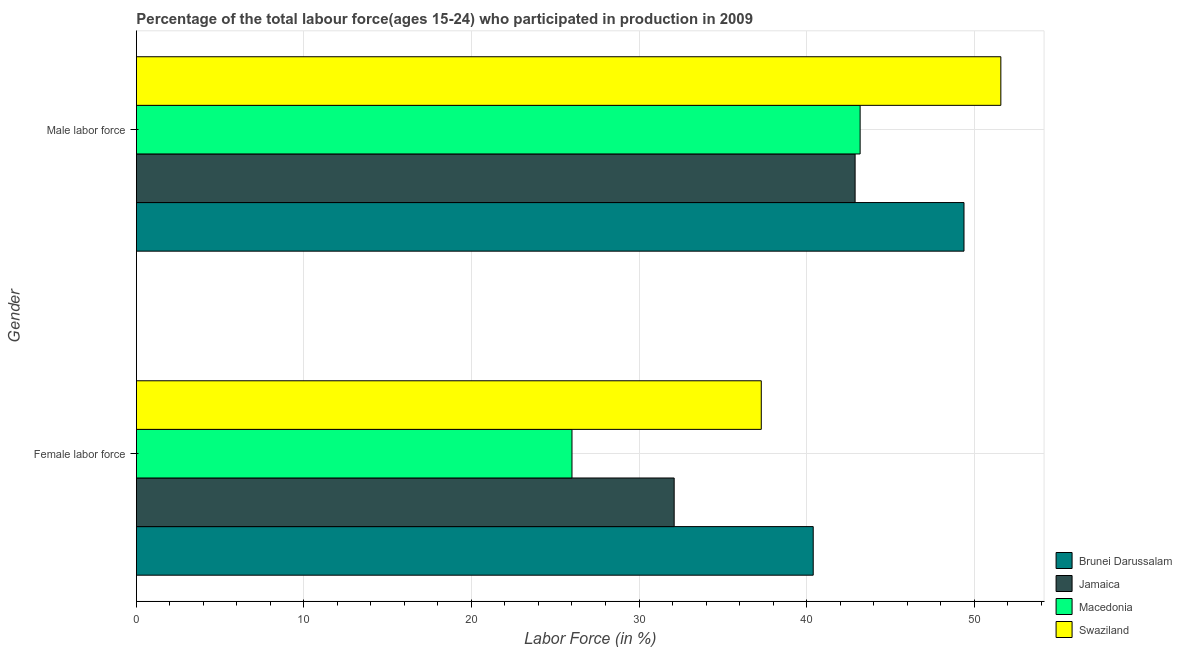How many groups of bars are there?
Give a very brief answer. 2. Are the number of bars per tick equal to the number of legend labels?
Your response must be concise. Yes. What is the label of the 1st group of bars from the top?
Your answer should be very brief. Male labor force. What is the percentage of male labour force in Brunei Darussalam?
Make the answer very short. 49.4. Across all countries, what is the maximum percentage of male labour force?
Your answer should be compact. 51.6. Across all countries, what is the minimum percentage of male labour force?
Offer a very short reply. 42.9. In which country was the percentage of female labor force maximum?
Provide a succinct answer. Brunei Darussalam. In which country was the percentage of male labour force minimum?
Offer a terse response. Jamaica. What is the total percentage of female labor force in the graph?
Your response must be concise. 135.8. What is the difference between the percentage of female labor force in Macedonia and that in Jamaica?
Keep it short and to the point. -6.1. What is the difference between the percentage of male labour force in Brunei Darussalam and the percentage of female labor force in Jamaica?
Ensure brevity in your answer.  17.3. What is the average percentage of male labour force per country?
Make the answer very short. 46.78. What is the difference between the percentage of female labor force and percentage of male labour force in Brunei Darussalam?
Your answer should be very brief. -9. What is the ratio of the percentage of male labour force in Swaziland to that in Macedonia?
Ensure brevity in your answer.  1.19. In how many countries, is the percentage of female labor force greater than the average percentage of female labor force taken over all countries?
Your answer should be very brief. 2. What does the 2nd bar from the top in Male labor force represents?
Your response must be concise. Macedonia. What does the 4th bar from the bottom in Female labor force represents?
Provide a short and direct response. Swaziland. Are all the bars in the graph horizontal?
Make the answer very short. Yes. How many countries are there in the graph?
Your answer should be compact. 4. Are the values on the major ticks of X-axis written in scientific E-notation?
Offer a very short reply. No. Where does the legend appear in the graph?
Offer a terse response. Bottom right. How many legend labels are there?
Your answer should be very brief. 4. What is the title of the graph?
Offer a very short reply. Percentage of the total labour force(ages 15-24) who participated in production in 2009. Does "Botswana" appear as one of the legend labels in the graph?
Provide a succinct answer. No. What is the label or title of the Y-axis?
Give a very brief answer. Gender. What is the Labor Force (in %) in Brunei Darussalam in Female labor force?
Make the answer very short. 40.4. What is the Labor Force (in %) in Jamaica in Female labor force?
Your answer should be compact. 32.1. What is the Labor Force (in %) of Macedonia in Female labor force?
Make the answer very short. 26. What is the Labor Force (in %) of Swaziland in Female labor force?
Keep it short and to the point. 37.3. What is the Labor Force (in %) of Brunei Darussalam in Male labor force?
Your answer should be very brief. 49.4. What is the Labor Force (in %) in Jamaica in Male labor force?
Your answer should be very brief. 42.9. What is the Labor Force (in %) in Macedonia in Male labor force?
Offer a terse response. 43.2. What is the Labor Force (in %) of Swaziland in Male labor force?
Offer a terse response. 51.6. Across all Gender, what is the maximum Labor Force (in %) in Brunei Darussalam?
Your answer should be very brief. 49.4. Across all Gender, what is the maximum Labor Force (in %) in Jamaica?
Your answer should be compact. 42.9. Across all Gender, what is the maximum Labor Force (in %) in Macedonia?
Your answer should be very brief. 43.2. Across all Gender, what is the maximum Labor Force (in %) of Swaziland?
Ensure brevity in your answer.  51.6. Across all Gender, what is the minimum Labor Force (in %) in Brunei Darussalam?
Your answer should be very brief. 40.4. Across all Gender, what is the minimum Labor Force (in %) of Jamaica?
Give a very brief answer. 32.1. Across all Gender, what is the minimum Labor Force (in %) of Swaziland?
Your answer should be very brief. 37.3. What is the total Labor Force (in %) of Brunei Darussalam in the graph?
Give a very brief answer. 89.8. What is the total Labor Force (in %) of Macedonia in the graph?
Offer a very short reply. 69.2. What is the total Labor Force (in %) of Swaziland in the graph?
Your response must be concise. 88.9. What is the difference between the Labor Force (in %) in Macedonia in Female labor force and that in Male labor force?
Offer a very short reply. -17.2. What is the difference between the Labor Force (in %) of Swaziland in Female labor force and that in Male labor force?
Ensure brevity in your answer.  -14.3. What is the difference between the Labor Force (in %) in Brunei Darussalam in Female labor force and the Labor Force (in %) in Jamaica in Male labor force?
Make the answer very short. -2.5. What is the difference between the Labor Force (in %) of Jamaica in Female labor force and the Labor Force (in %) of Swaziland in Male labor force?
Your response must be concise. -19.5. What is the difference between the Labor Force (in %) of Macedonia in Female labor force and the Labor Force (in %) of Swaziland in Male labor force?
Offer a terse response. -25.6. What is the average Labor Force (in %) of Brunei Darussalam per Gender?
Ensure brevity in your answer.  44.9. What is the average Labor Force (in %) of Jamaica per Gender?
Your answer should be very brief. 37.5. What is the average Labor Force (in %) in Macedonia per Gender?
Offer a terse response. 34.6. What is the average Labor Force (in %) in Swaziland per Gender?
Provide a succinct answer. 44.45. What is the difference between the Labor Force (in %) in Brunei Darussalam and Labor Force (in %) in Jamaica in Female labor force?
Your answer should be compact. 8.3. What is the difference between the Labor Force (in %) of Brunei Darussalam and Labor Force (in %) of Macedonia in Female labor force?
Keep it short and to the point. 14.4. What is the difference between the Labor Force (in %) in Brunei Darussalam and Labor Force (in %) in Swaziland in Female labor force?
Make the answer very short. 3.1. What is the difference between the Labor Force (in %) of Jamaica and Labor Force (in %) of Swaziland in Male labor force?
Provide a short and direct response. -8.7. What is the difference between the Labor Force (in %) of Macedonia and Labor Force (in %) of Swaziland in Male labor force?
Make the answer very short. -8.4. What is the ratio of the Labor Force (in %) of Brunei Darussalam in Female labor force to that in Male labor force?
Ensure brevity in your answer.  0.82. What is the ratio of the Labor Force (in %) of Jamaica in Female labor force to that in Male labor force?
Ensure brevity in your answer.  0.75. What is the ratio of the Labor Force (in %) of Macedonia in Female labor force to that in Male labor force?
Give a very brief answer. 0.6. What is the ratio of the Labor Force (in %) of Swaziland in Female labor force to that in Male labor force?
Offer a very short reply. 0.72. What is the difference between the highest and the second highest Labor Force (in %) in Brunei Darussalam?
Provide a short and direct response. 9. What is the difference between the highest and the second highest Labor Force (in %) of Swaziland?
Provide a succinct answer. 14.3. What is the difference between the highest and the lowest Labor Force (in %) of Brunei Darussalam?
Your response must be concise. 9. What is the difference between the highest and the lowest Labor Force (in %) of Jamaica?
Make the answer very short. 10.8. 